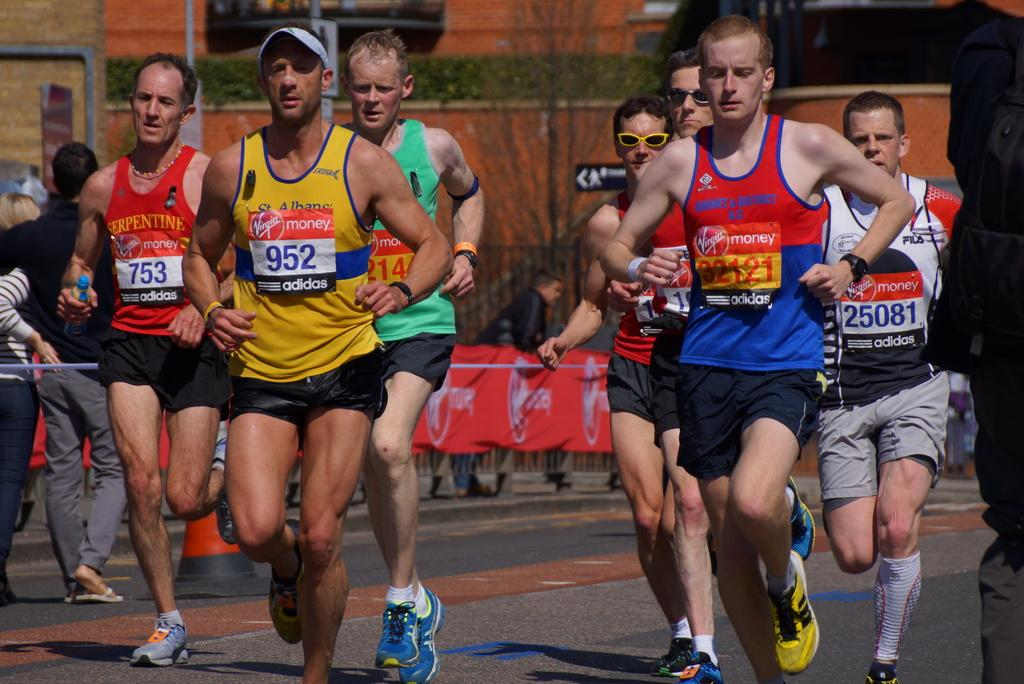What is happening in the image involving the group of men? The men are running on the road in the image. What can be seen in the background of the image? There is a banner, trees, pipes, and persons standing at a fence in the background of the image. What type of boat can be seen in the image? There is no boat present in the image; it features a group of men running on the road and various elements in the background. How many eggs are visible in the image? There are no eggs present in the image. 